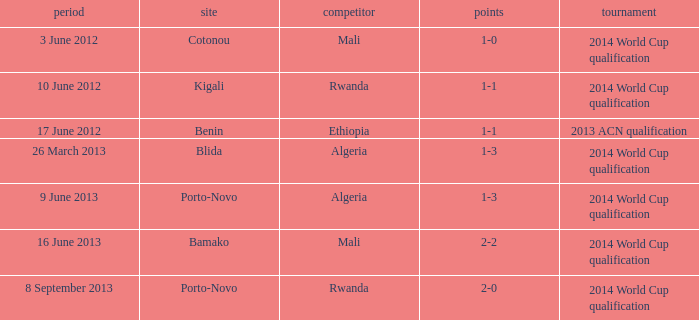What competition is located in bamako? 2014 World Cup qualification. 